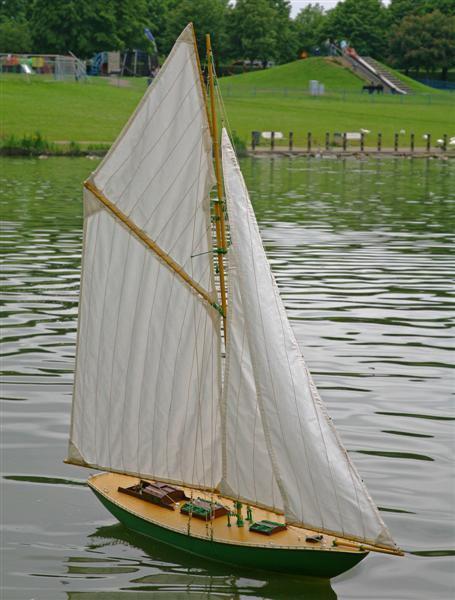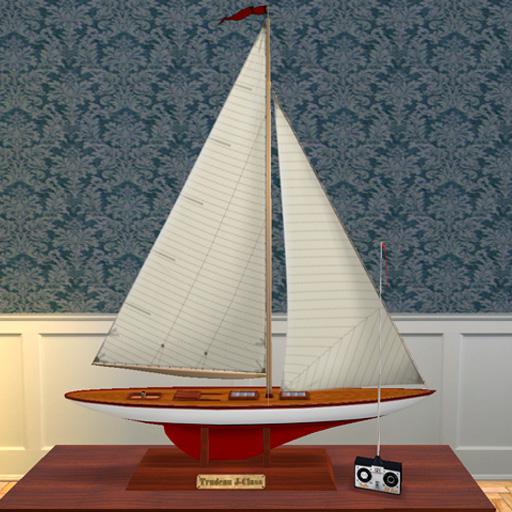The first image is the image on the left, the second image is the image on the right. For the images shown, is this caption "Each image shows a boat on the water, and at least one of the boats looks like a wooden model instead of a full-size boat." true? Answer yes or no. No. The first image is the image on the left, the second image is the image on the right. Evaluate the accuracy of this statement regarding the images: "Both of the boats are in the water.". Is it true? Answer yes or no. No. 